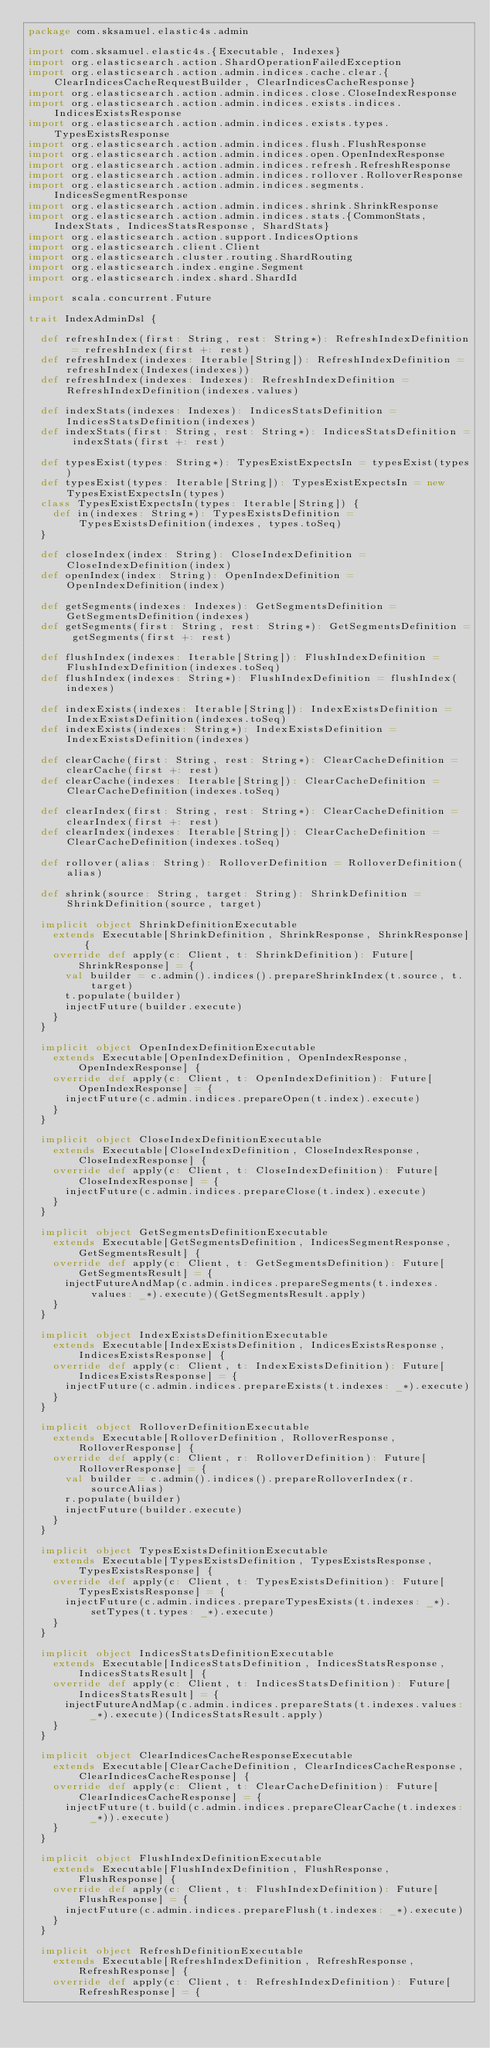<code> <loc_0><loc_0><loc_500><loc_500><_Scala_>package com.sksamuel.elastic4s.admin

import com.sksamuel.elastic4s.{Executable, Indexes}
import org.elasticsearch.action.ShardOperationFailedException
import org.elasticsearch.action.admin.indices.cache.clear.{ClearIndicesCacheRequestBuilder, ClearIndicesCacheResponse}
import org.elasticsearch.action.admin.indices.close.CloseIndexResponse
import org.elasticsearch.action.admin.indices.exists.indices.IndicesExistsResponse
import org.elasticsearch.action.admin.indices.exists.types.TypesExistsResponse
import org.elasticsearch.action.admin.indices.flush.FlushResponse
import org.elasticsearch.action.admin.indices.open.OpenIndexResponse
import org.elasticsearch.action.admin.indices.refresh.RefreshResponse
import org.elasticsearch.action.admin.indices.rollover.RolloverResponse
import org.elasticsearch.action.admin.indices.segments.IndicesSegmentResponse
import org.elasticsearch.action.admin.indices.shrink.ShrinkResponse
import org.elasticsearch.action.admin.indices.stats.{CommonStats, IndexStats, IndicesStatsResponse, ShardStats}
import org.elasticsearch.action.support.IndicesOptions
import org.elasticsearch.client.Client
import org.elasticsearch.cluster.routing.ShardRouting
import org.elasticsearch.index.engine.Segment
import org.elasticsearch.index.shard.ShardId

import scala.concurrent.Future

trait IndexAdminDsl {

  def refreshIndex(first: String, rest: String*): RefreshIndexDefinition = refreshIndex(first +: rest)
  def refreshIndex(indexes: Iterable[String]): RefreshIndexDefinition = refreshIndex(Indexes(indexes))
  def refreshIndex(indexes: Indexes): RefreshIndexDefinition = RefreshIndexDefinition(indexes.values)

  def indexStats(indexes: Indexes): IndicesStatsDefinition = IndicesStatsDefinition(indexes)
  def indexStats(first: String, rest: String*): IndicesStatsDefinition = indexStats(first +: rest)

  def typesExist(types: String*): TypesExistExpectsIn = typesExist(types)
  def typesExist(types: Iterable[String]): TypesExistExpectsIn = new TypesExistExpectsIn(types)
  class TypesExistExpectsIn(types: Iterable[String]) {
    def in(indexes: String*): TypesExistsDefinition = TypesExistsDefinition(indexes, types.toSeq)
  }

  def closeIndex(index: String): CloseIndexDefinition = CloseIndexDefinition(index)
  def openIndex(index: String): OpenIndexDefinition = OpenIndexDefinition(index)

  def getSegments(indexes: Indexes): GetSegmentsDefinition = GetSegmentsDefinition(indexes)
  def getSegments(first: String, rest: String*): GetSegmentsDefinition = getSegments(first +: rest)

  def flushIndex(indexes: Iterable[String]): FlushIndexDefinition = FlushIndexDefinition(indexes.toSeq)
  def flushIndex(indexes: String*): FlushIndexDefinition = flushIndex(indexes)

  def indexExists(indexes: Iterable[String]): IndexExistsDefinition = IndexExistsDefinition(indexes.toSeq)
  def indexExists(indexes: String*): IndexExistsDefinition = IndexExistsDefinition(indexes)

  def clearCache(first: String, rest: String*): ClearCacheDefinition = clearCache(first +: rest)
  def clearCache(indexes: Iterable[String]): ClearCacheDefinition = ClearCacheDefinition(indexes.toSeq)

  def clearIndex(first: String, rest: String*): ClearCacheDefinition = clearIndex(first +: rest)
  def clearIndex(indexes: Iterable[String]): ClearCacheDefinition = ClearCacheDefinition(indexes.toSeq)

  def rollover(alias: String): RolloverDefinition = RolloverDefinition(alias)

  def shrink(source: String, target: String): ShrinkDefinition = ShrinkDefinition(source, target)

  implicit object ShrinkDefinitionExecutable
    extends Executable[ShrinkDefinition, ShrinkResponse, ShrinkResponse] {
    override def apply(c: Client, t: ShrinkDefinition): Future[ShrinkResponse] = {
      val builder = c.admin().indices().prepareShrinkIndex(t.source, t.target)
      t.populate(builder)
      injectFuture(builder.execute)
    }
  }

  implicit object OpenIndexDefinitionExecutable
    extends Executable[OpenIndexDefinition, OpenIndexResponse, OpenIndexResponse] {
    override def apply(c: Client, t: OpenIndexDefinition): Future[OpenIndexResponse] = {
      injectFuture(c.admin.indices.prepareOpen(t.index).execute)
    }
  }

  implicit object CloseIndexDefinitionExecutable
    extends Executable[CloseIndexDefinition, CloseIndexResponse, CloseIndexResponse] {
    override def apply(c: Client, t: CloseIndexDefinition): Future[CloseIndexResponse] = {
      injectFuture(c.admin.indices.prepareClose(t.index).execute)
    }
  }

  implicit object GetSegmentsDefinitionExecutable
    extends Executable[GetSegmentsDefinition, IndicesSegmentResponse, GetSegmentsResult] {
    override def apply(c: Client, t: GetSegmentsDefinition): Future[GetSegmentsResult] = {
      injectFutureAndMap(c.admin.indices.prepareSegments(t.indexes.values: _*).execute)(GetSegmentsResult.apply)
    }
  }

  implicit object IndexExistsDefinitionExecutable
    extends Executable[IndexExistsDefinition, IndicesExistsResponse, IndicesExistsResponse] {
    override def apply(c: Client, t: IndexExistsDefinition): Future[IndicesExistsResponse] = {
      injectFuture(c.admin.indices.prepareExists(t.indexes: _*).execute)
    }
  }

  implicit object RolloverDefinitionExecutable
    extends Executable[RolloverDefinition, RolloverResponse, RolloverResponse] {
    override def apply(c: Client, r: RolloverDefinition): Future[RolloverResponse] = {
      val builder = c.admin().indices().prepareRolloverIndex(r.sourceAlias)
      r.populate(builder)
      injectFuture(builder.execute)
    }
  }

  implicit object TypesExistsDefinitionExecutable
    extends Executable[TypesExistsDefinition, TypesExistsResponse, TypesExistsResponse] {
    override def apply(c: Client, t: TypesExistsDefinition): Future[TypesExistsResponse] = {
      injectFuture(c.admin.indices.prepareTypesExists(t.indexes: _*).setTypes(t.types: _*).execute)
    }
  }

  implicit object IndicesStatsDefinitionExecutable
    extends Executable[IndicesStatsDefinition, IndicesStatsResponse, IndicesStatsResult] {
    override def apply(c: Client, t: IndicesStatsDefinition): Future[IndicesStatsResult] = {
      injectFutureAndMap(c.admin.indices.prepareStats(t.indexes.values: _*).execute)(IndicesStatsResult.apply)
    }
  }

  implicit object ClearIndicesCacheResponseExecutable
    extends Executable[ClearCacheDefinition, ClearIndicesCacheResponse, ClearIndicesCacheResponse] {
    override def apply(c: Client, t: ClearCacheDefinition): Future[ClearIndicesCacheResponse] = {
      injectFuture(t.build(c.admin.indices.prepareClearCache(t.indexes: _*)).execute)
    }
  }

  implicit object FlushIndexDefinitionExecutable
    extends Executable[FlushIndexDefinition, FlushResponse, FlushResponse] {
    override def apply(c: Client, t: FlushIndexDefinition): Future[FlushResponse] = {
      injectFuture(c.admin.indices.prepareFlush(t.indexes: _*).execute)
    }
  }

  implicit object RefreshDefinitionExecutable
    extends Executable[RefreshIndexDefinition, RefreshResponse, RefreshResponse] {
    override def apply(c: Client, t: RefreshIndexDefinition): Future[RefreshResponse] = {</code> 